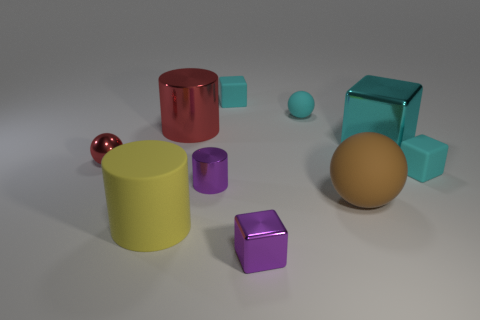Subtract all small purple metal blocks. How many blocks are left? 3 Subtract all gray spheres. How many cyan cubes are left? 3 Subtract 2 blocks. How many blocks are left? 2 Subtract all purple blocks. How many blocks are left? 3 Subtract all yellow balls. Subtract all blue cylinders. How many balls are left? 3 Subtract all cylinders. How many objects are left? 7 Subtract all small balls. Subtract all big metal cubes. How many objects are left? 7 Add 9 large brown matte balls. How many large brown matte balls are left? 10 Add 1 gray balls. How many gray balls exist? 1 Subtract 0 yellow spheres. How many objects are left? 10 